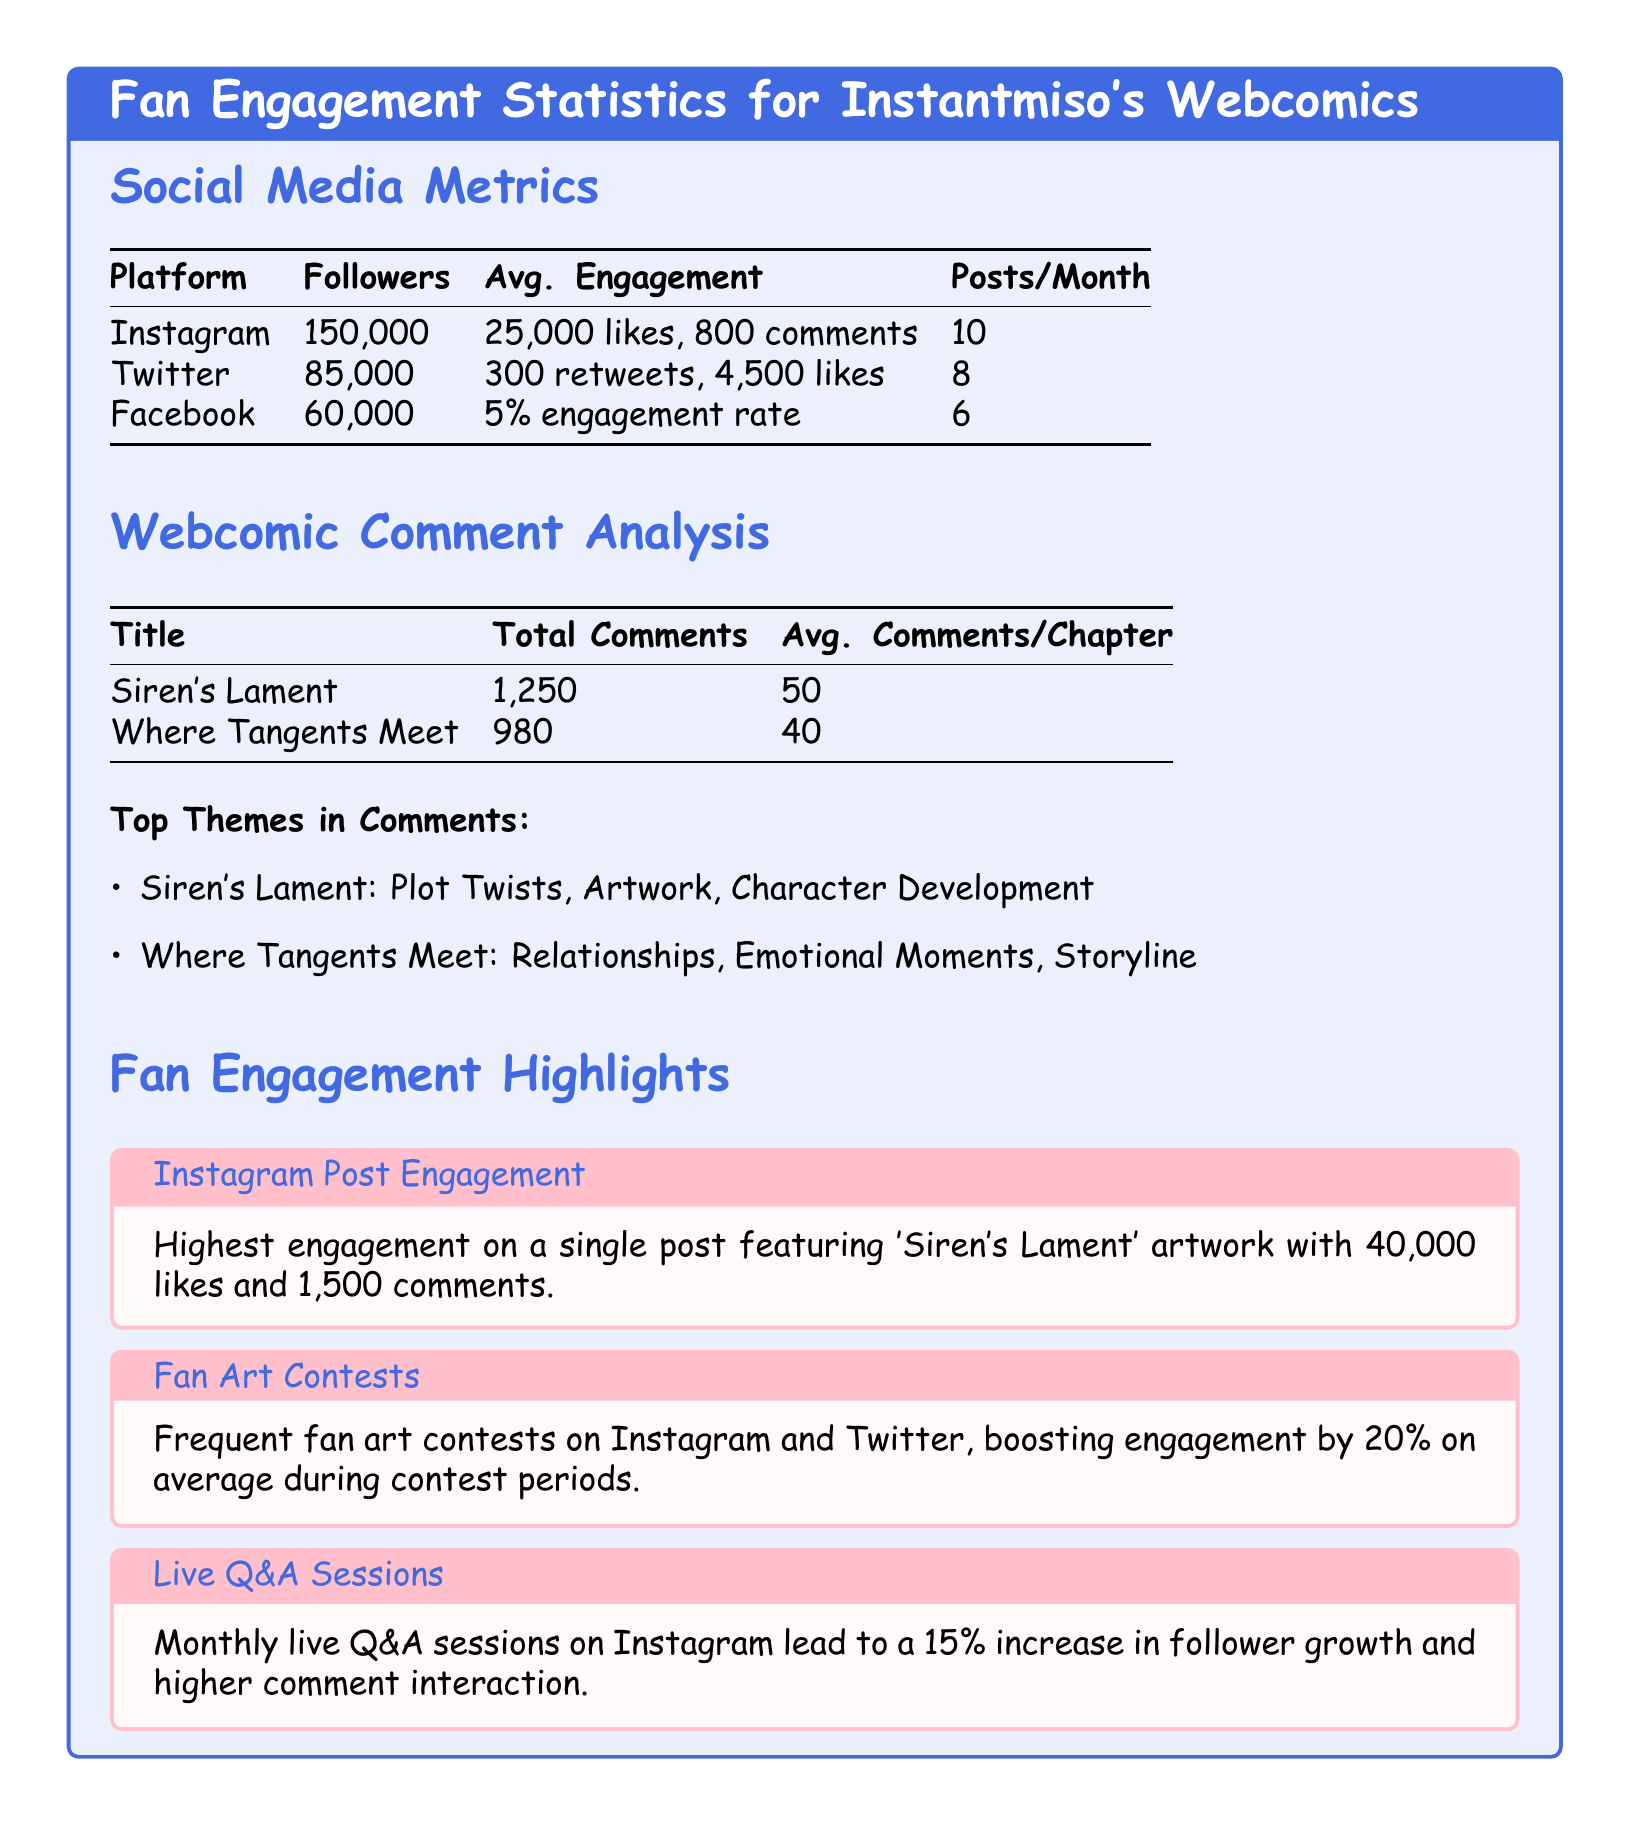What is the total number of followers on Instagram? The document states that Instantmiso has 150,000 followers on Instagram.
Answer: 150,000 What is the average engagement on Twitter? According to the data, the average engagement on Twitter is 300 retweets and 4,500 likes.
Answer: 300 retweets, 4,500 likes How many posts are made monthly on Facebook? The document indicates that 6 posts are made per month on Facebook.
Answer: 6 What is the total number of comments for 'Siren's Lament'? The number of total comments for 'Siren's Lament' is listed as 1,250.
Answer: 1,250 Which webcomic has a higher average comments per chapter? By comparing the average comments per chapter, 'Siren's Lament' has 50 while 'Where Tangents Meet' has 40, indicating 'Siren's Lament' has a higher count.
Answer: Siren's Lament What are the top themes in comments for 'Where Tangents Meet'? The themes listed in the comments for 'Where Tangents Meet' are relationships, emotional moments, and storyline.
Answer: Relationships, Emotional Moments, Storyline What was the highest engagement on a single Instagram post? The highest engagement on a single Instagram post featuring 'Siren's Lament' artwork had 40,000 likes and 1,500 comments.
Answer: 40,000 likes, 1,500 comments How much does fan art contests boost engagement on average? The document states that fan art contests boost engagement by 20% on average during contest periods.
Answer: 20% What percentage increase in follower growth do monthly live Q&A sessions lead to? The document mentions that these sessions lead to a 15% increase in follower growth.
Answer: 15% 